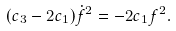<formula> <loc_0><loc_0><loc_500><loc_500>( c _ { 3 } - 2 c _ { 1 } ) \dot { f } ^ { 2 } = - 2 c _ { 1 } f ^ { 2 } .</formula> 